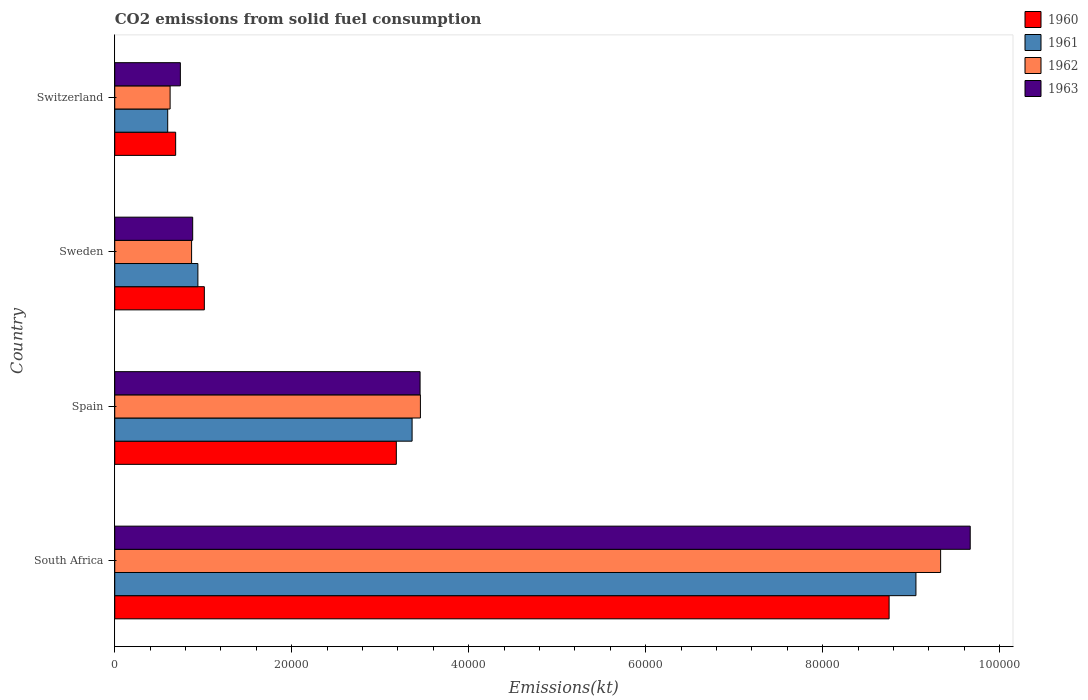How many different coloured bars are there?
Offer a terse response. 4. How many groups of bars are there?
Make the answer very short. 4. How many bars are there on the 1st tick from the top?
Give a very brief answer. 4. How many bars are there on the 3rd tick from the bottom?
Give a very brief answer. 4. What is the label of the 2nd group of bars from the top?
Keep it short and to the point. Sweden. What is the amount of CO2 emitted in 1961 in South Africa?
Ensure brevity in your answer.  9.05e+04. Across all countries, what is the maximum amount of CO2 emitted in 1960?
Keep it short and to the point. 8.75e+04. Across all countries, what is the minimum amount of CO2 emitted in 1963?
Provide a short and direct response. 7414.67. In which country was the amount of CO2 emitted in 1960 maximum?
Provide a short and direct response. South Africa. In which country was the amount of CO2 emitted in 1960 minimum?
Make the answer very short. Switzerland. What is the total amount of CO2 emitted in 1960 in the graph?
Make the answer very short. 1.36e+05. What is the difference between the amount of CO2 emitted in 1963 in Sweden and that in Switzerland?
Your answer should be compact. 1393.46. What is the difference between the amount of CO2 emitted in 1960 in South Africa and the amount of CO2 emitted in 1963 in Spain?
Offer a very short reply. 5.30e+04. What is the average amount of CO2 emitted in 1961 per country?
Keep it short and to the point. 3.49e+04. What is the difference between the amount of CO2 emitted in 1962 and amount of CO2 emitted in 1961 in Switzerland?
Make the answer very short. 271.36. What is the ratio of the amount of CO2 emitted in 1960 in South Africa to that in Spain?
Your response must be concise. 2.75. Is the amount of CO2 emitted in 1963 in Spain less than that in Sweden?
Offer a terse response. No. Is the difference between the amount of CO2 emitted in 1962 in Spain and Sweden greater than the difference between the amount of CO2 emitted in 1961 in Spain and Sweden?
Your response must be concise. Yes. What is the difference between the highest and the second highest amount of CO2 emitted in 1961?
Your answer should be compact. 5.69e+04. What is the difference between the highest and the lowest amount of CO2 emitted in 1962?
Ensure brevity in your answer.  8.71e+04. Is the sum of the amount of CO2 emitted in 1963 in South Africa and Spain greater than the maximum amount of CO2 emitted in 1962 across all countries?
Keep it short and to the point. Yes. Is it the case that in every country, the sum of the amount of CO2 emitted in 1963 and amount of CO2 emitted in 1962 is greater than the sum of amount of CO2 emitted in 1960 and amount of CO2 emitted in 1961?
Provide a short and direct response. No. Are all the bars in the graph horizontal?
Ensure brevity in your answer.  Yes. Are the values on the major ticks of X-axis written in scientific E-notation?
Ensure brevity in your answer.  No. Does the graph contain any zero values?
Offer a very short reply. No. How many legend labels are there?
Provide a succinct answer. 4. How are the legend labels stacked?
Provide a succinct answer. Vertical. What is the title of the graph?
Provide a succinct answer. CO2 emissions from solid fuel consumption. Does "1992" appear as one of the legend labels in the graph?
Your response must be concise. No. What is the label or title of the X-axis?
Give a very brief answer. Emissions(kt). What is the label or title of the Y-axis?
Make the answer very short. Country. What is the Emissions(kt) in 1960 in South Africa?
Your response must be concise. 8.75e+04. What is the Emissions(kt) in 1961 in South Africa?
Keep it short and to the point. 9.05e+04. What is the Emissions(kt) of 1962 in South Africa?
Offer a terse response. 9.33e+04. What is the Emissions(kt) in 1963 in South Africa?
Your response must be concise. 9.67e+04. What is the Emissions(kt) in 1960 in Spain?
Ensure brevity in your answer.  3.18e+04. What is the Emissions(kt) in 1961 in Spain?
Ensure brevity in your answer.  3.36e+04. What is the Emissions(kt) in 1962 in Spain?
Make the answer very short. 3.45e+04. What is the Emissions(kt) in 1963 in Spain?
Your response must be concise. 3.45e+04. What is the Emissions(kt) of 1960 in Sweden?
Offer a very short reply. 1.01e+04. What is the Emissions(kt) of 1961 in Sweden?
Provide a short and direct response. 9394.85. What is the Emissions(kt) of 1962 in Sweden?
Ensure brevity in your answer.  8683.46. What is the Emissions(kt) in 1963 in Sweden?
Offer a very short reply. 8808.13. What is the Emissions(kt) of 1960 in Switzerland?
Give a very brief answer. 6882.96. What is the Emissions(kt) of 1961 in Switzerland?
Ensure brevity in your answer.  5984.54. What is the Emissions(kt) in 1962 in Switzerland?
Your answer should be very brief. 6255.9. What is the Emissions(kt) of 1963 in Switzerland?
Make the answer very short. 7414.67. Across all countries, what is the maximum Emissions(kt) of 1960?
Ensure brevity in your answer.  8.75e+04. Across all countries, what is the maximum Emissions(kt) of 1961?
Ensure brevity in your answer.  9.05e+04. Across all countries, what is the maximum Emissions(kt) in 1962?
Provide a short and direct response. 9.33e+04. Across all countries, what is the maximum Emissions(kt) in 1963?
Ensure brevity in your answer.  9.67e+04. Across all countries, what is the minimum Emissions(kt) in 1960?
Keep it short and to the point. 6882.96. Across all countries, what is the minimum Emissions(kt) of 1961?
Give a very brief answer. 5984.54. Across all countries, what is the minimum Emissions(kt) of 1962?
Provide a short and direct response. 6255.9. Across all countries, what is the minimum Emissions(kt) in 1963?
Give a very brief answer. 7414.67. What is the total Emissions(kt) of 1960 in the graph?
Your answer should be compact. 1.36e+05. What is the total Emissions(kt) in 1961 in the graph?
Make the answer very short. 1.40e+05. What is the total Emissions(kt) in 1962 in the graph?
Your answer should be very brief. 1.43e+05. What is the total Emissions(kt) of 1963 in the graph?
Provide a short and direct response. 1.47e+05. What is the difference between the Emissions(kt) in 1960 in South Africa and that in Spain?
Ensure brevity in your answer.  5.57e+04. What is the difference between the Emissions(kt) of 1961 in South Africa and that in Spain?
Give a very brief answer. 5.69e+04. What is the difference between the Emissions(kt) in 1962 in South Africa and that in Spain?
Your answer should be very brief. 5.88e+04. What is the difference between the Emissions(kt) of 1963 in South Africa and that in Spain?
Provide a short and direct response. 6.22e+04. What is the difference between the Emissions(kt) in 1960 in South Africa and that in Sweden?
Offer a terse response. 7.74e+04. What is the difference between the Emissions(kt) of 1961 in South Africa and that in Sweden?
Your answer should be compact. 8.12e+04. What is the difference between the Emissions(kt) in 1962 in South Africa and that in Sweden?
Your response must be concise. 8.47e+04. What is the difference between the Emissions(kt) in 1963 in South Africa and that in Sweden?
Keep it short and to the point. 8.79e+04. What is the difference between the Emissions(kt) of 1960 in South Africa and that in Switzerland?
Provide a short and direct response. 8.06e+04. What is the difference between the Emissions(kt) of 1961 in South Africa and that in Switzerland?
Keep it short and to the point. 8.46e+04. What is the difference between the Emissions(kt) in 1962 in South Africa and that in Switzerland?
Your answer should be very brief. 8.71e+04. What is the difference between the Emissions(kt) of 1963 in South Africa and that in Switzerland?
Offer a terse response. 8.93e+04. What is the difference between the Emissions(kt) of 1960 in Spain and that in Sweden?
Your answer should be very brief. 2.17e+04. What is the difference between the Emissions(kt) of 1961 in Spain and that in Sweden?
Your answer should be compact. 2.42e+04. What is the difference between the Emissions(kt) of 1962 in Spain and that in Sweden?
Your answer should be compact. 2.59e+04. What is the difference between the Emissions(kt) in 1963 in Spain and that in Sweden?
Your answer should be very brief. 2.57e+04. What is the difference between the Emissions(kt) of 1960 in Spain and that in Switzerland?
Keep it short and to the point. 2.49e+04. What is the difference between the Emissions(kt) of 1961 in Spain and that in Switzerland?
Provide a succinct answer. 2.76e+04. What is the difference between the Emissions(kt) in 1962 in Spain and that in Switzerland?
Provide a short and direct response. 2.83e+04. What is the difference between the Emissions(kt) in 1963 in Spain and that in Switzerland?
Give a very brief answer. 2.71e+04. What is the difference between the Emissions(kt) in 1960 in Sweden and that in Switzerland?
Offer a terse response. 3241.63. What is the difference between the Emissions(kt) in 1961 in Sweden and that in Switzerland?
Offer a terse response. 3410.31. What is the difference between the Emissions(kt) in 1962 in Sweden and that in Switzerland?
Offer a very short reply. 2427.55. What is the difference between the Emissions(kt) in 1963 in Sweden and that in Switzerland?
Ensure brevity in your answer.  1393.46. What is the difference between the Emissions(kt) of 1960 in South Africa and the Emissions(kt) of 1961 in Spain?
Your answer should be very brief. 5.39e+04. What is the difference between the Emissions(kt) in 1960 in South Africa and the Emissions(kt) in 1962 in Spain?
Your answer should be compact. 5.30e+04. What is the difference between the Emissions(kt) of 1960 in South Africa and the Emissions(kt) of 1963 in Spain?
Ensure brevity in your answer.  5.30e+04. What is the difference between the Emissions(kt) of 1961 in South Africa and the Emissions(kt) of 1962 in Spain?
Make the answer very short. 5.60e+04. What is the difference between the Emissions(kt) in 1961 in South Africa and the Emissions(kt) in 1963 in Spain?
Offer a terse response. 5.60e+04. What is the difference between the Emissions(kt) in 1962 in South Africa and the Emissions(kt) in 1963 in Spain?
Offer a very short reply. 5.88e+04. What is the difference between the Emissions(kt) of 1960 in South Africa and the Emissions(kt) of 1961 in Sweden?
Give a very brief answer. 7.81e+04. What is the difference between the Emissions(kt) of 1960 in South Africa and the Emissions(kt) of 1962 in Sweden?
Offer a very short reply. 7.88e+04. What is the difference between the Emissions(kt) in 1960 in South Africa and the Emissions(kt) in 1963 in Sweden?
Offer a terse response. 7.87e+04. What is the difference between the Emissions(kt) of 1961 in South Africa and the Emissions(kt) of 1962 in Sweden?
Keep it short and to the point. 8.19e+04. What is the difference between the Emissions(kt) in 1961 in South Africa and the Emissions(kt) in 1963 in Sweden?
Give a very brief answer. 8.17e+04. What is the difference between the Emissions(kt) of 1962 in South Africa and the Emissions(kt) of 1963 in Sweden?
Keep it short and to the point. 8.45e+04. What is the difference between the Emissions(kt) in 1960 in South Africa and the Emissions(kt) in 1961 in Switzerland?
Ensure brevity in your answer.  8.15e+04. What is the difference between the Emissions(kt) of 1960 in South Africa and the Emissions(kt) of 1962 in Switzerland?
Provide a short and direct response. 8.13e+04. What is the difference between the Emissions(kt) of 1960 in South Africa and the Emissions(kt) of 1963 in Switzerland?
Your response must be concise. 8.01e+04. What is the difference between the Emissions(kt) of 1961 in South Africa and the Emissions(kt) of 1962 in Switzerland?
Make the answer very short. 8.43e+04. What is the difference between the Emissions(kt) in 1961 in South Africa and the Emissions(kt) in 1963 in Switzerland?
Your response must be concise. 8.31e+04. What is the difference between the Emissions(kt) of 1962 in South Africa and the Emissions(kt) of 1963 in Switzerland?
Provide a succinct answer. 8.59e+04. What is the difference between the Emissions(kt) of 1960 in Spain and the Emissions(kt) of 1961 in Sweden?
Offer a terse response. 2.24e+04. What is the difference between the Emissions(kt) of 1960 in Spain and the Emissions(kt) of 1962 in Sweden?
Make the answer very short. 2.31e+04. What is the difference between the Emissions(kt) in 1960 in Spain and the Emissions(kt) in 1963 in Sweden?
Your answer should be very brief. 2.30e+04. What is the difference between the Emissions(kt) in 1961 in Spain and the Emissions(kt) in 1962 in Sweden?
Make the answer very short. 2.49e+04. What is the difference between the Emissions(kt) of 1961 in Spain and the Emissions(kt) of 1963 in Sweden?
Your response must be concise. 2.48e+04. What is the difference between the Emissions(kt) in 1962 in Spain and the Emissions(kt) in 1963 in Sweden?
Provide a succinct answer. 2.57e+04. What is the difference between the Emissions(kt) in 1960 in Spain and the Emissions(kt) in 1961 in Switzerland?
Give a very brief answer. 2.58e+04. What is the difference between the Emissions(kt) of 1960 in Spain and the Emissions(kt) of 1962 in Switzerland?
Give a very brief answer. 2.56e+04. What is the difference between the Emissions(kt) in 1960 in Spain and the Emissions(kt) in 1963 in Switzerland?
Keep it short and to the point. 2.44e+04. What is the difference between the Emissions(kt) of 1961 in Spain and the Emissions(kt) of 1962 in Switzerland?
Your response must be concise. 2.73e+04. What is the difference between the Emissions(kt) in 1961 in Spain and the Emissions(kt) in 1963 in Switzerland?
Your answer should be very brief. 2.62e+04. What is the difference between the Emissions(kt) of 1962 in Spain and the Emissions(kt) of 1963 in Switzerland?
Keep it short and to the point. 2.71e+04. What is the difference between the Emissions(kt) of 1960 in Sweden and the Emissions(kt) of 1961 in Switzerland?
Keep it short and to the point. 4140.04. What is the difference between the Emissions(kt) of 1960 in Sweden and the Emissions(kt) of 1962 in Switzerland?
Offer a terse response. 3868.68. What is the difference between the Emissions(kt) in 1960 in Sweden and the Emissions(kt) in 1963 in Switzerland?
Your answer should be compact. 2709.91. What is the difference between the Emissions(kt) in 1961 in Sweden and the Emissions(kt) in 1962 in Switzerland?
Make the answer very short. 3138.95. What is the difference between the Emissions(kt) in 1961 in Sweden and the Emissions(kt) in 1963 in Switzerland?
Ensure brevity in your answer.  1980.18. What is the difference between the Emissions(kt) of 1962 in Sweden and the Emissions(kt) of 1963 in Switzerland?
Your answer should be very brief. 1268.78. What is the average Emissions(kt) of 1960 per country?
Ensure brevity in your answer.  3.41e+04. What is the average Emissions(kt) in 1961 per country?
Your answer should be compact. 3.49e+04. What is the average Emissions(kt) of 1962 per country?
Offer a very short reply. 3.57e+04. What is the average Emissions(kt) of 1963 per country?
Your answer should be compact. 3.69e+04. What is the difference between the Emissions(kt) of 1960 and Emissions(kt) of 1961 in South Africa?
Your response must be concise. -3032.61. What is the difference between the Emissions(kt) in 1960 and Emissions(kt) in 1962 in South Africa?
Ensure brevity in your answer.  -5823.2. What is the difference between the Emissions(kt) of 1960 and Emissions(kt) of 1963 in South Africa?
Ensure brevity in your answer.  -9167.5. What is the difference between the Emissions(kt) of 1961 and Emissions(kt) of 1962 in South Africa?
Make the answer very short. -2790.59. What is the difference between the Emissions(kt) of 1961 and Emissions(kt) of 1963 in South Africa?
Make the answer very short. -6134.89. What is the difference between the Emissions(kt) of 1962 and Emissions(kt) of 1963 in South Africa?
Give a very brief answer. -3344.3. What is the difference between the Emissions(kt) of 1960 and Emissions(kt) of 1961 in Spain?
Offer a terse response. -1782.16. What is the difference between the Emissions(kt) of 1960 and Emissions(kt) of 1962 in Spain?
Your answer should be compact. -2720.91. What is the difference between the Emissions(kt) in 1960 and Emissions(kt) in 1963 in Spain?
Offer a very short reply. -2684.24. What is the difference between the Emissions(kt) in 1961 and Emissions(kt) in 1962 in Spain?
Your answer should be very brief. -938.75. What is the difference between the Emissions(kt) of 1961 and Emissions(kt) of 1963 in Spain?
Provide a short and direct response. -902.08. What is the difference between the Emissions(kt) in 1962 and Emissions(kt) in 1963 in Spain?
Offer a terse response. 36.67. What is the difference between the Emissions(kt) of 1960 and Emissions(kt) of 1961 in Sweden?
Keep it short and to the point. 729.73. What is the difference between the Emissions(kt) of 1960 and Emissions(kt) of 1962 in Sweden?
Your answer should be compact. 1441.13. What is the difference between the Emissions(kt) in 1960 and Emissions(kt) in 1963 in Sweden?
Provide a succinct answer. 1316.45. What is the difference between the Emissions(kt) of 1961 and Emissions(kt) of 1962 in Sweden?
Make the answer very short. 711.4. What is the difference between the Emissions(kt) in 1961 and Emissions(kt) in 1963 in Sweden?
Make the answer very short. 586.72. What is the difference between the Emissions(kt) of 1962 and Emissions(kt) of 1963 in Sweden?
Make the answer very short. -124.68. What is the difference between the Emissions(kt) of 1960 and Emissions(kt) of 1961 in Switzerland?
Your answer should be compact. 898.41. What is the difference between the Emissions(kt) of 1960 and Emissions(kt) of 1962 in Switzerland?
Make the answer very short. 627.06. What is the difference between the Emissions(kt) in 1960 and Emissions(kt) in 1963 in Switzerland?
Give a very brief answer. -531.72. What is the difference between the Emissions(kt) in 1961 and Emissions(kt) in 1962 in Switzerland?
Provide a succinct answer. -271.36. What is the difference between the Emissions(kt) of 1961 and Emissions(kt) of 1963 in Switzerland?
Your response must be concise. -1430.13. What is the difference between the Emissions(kt) in 1962 and Emissions(kt) in 1963 in Switzerland?
Your answer should be compact. -1158.77. What is the ratio of the Emissions(kt) in 1960 in South Africa to that in Spain?
Provide a succinct answer. 2.75. What is the ratio of the Emissions(kt) in 1961 in South Africa to that in Spain?
Keep it short and to the point. 2.69. What is the ratio of the Emissions(kt) of 1962 in South Africa to that in Spain?
Provide a succinct answer. 2.7. What is the ratio of the Emissions(kt) in 1963 in South Africa to that in Spain?
Give a very brief answer. 2.8. What is the ratio of the Emissions(kt) of 1960 in South Africa to that in Sweden?
Provide a short and direct response. 8.64. What is the ratio of the Emissions(kt) in 1961 in South Africa to that in Sweden?
Your answer should be very brief. 9.64. What is the ratio of the Emissions(kt) of 1962 in South Africa to that in Sweden?
Offer a terse response. 10.75. What is the ratio of the Emissions(kt) of 1963 in South Africa to that in Sweden?
Provide a succinct answer. 10.98. What is the ratio of the Emissions(kt) in 1960 in South Africa to that in Switzerland?
Give a very brief answer. 12.71. What is the ratio of the Emissions(kt) in 1961 in South Africa to that in Switzerland?
Ensure brevity in your answer.  15.13. What is the ratio of the Emissions(kt) in 1962 in South Africa to that in Switzerland?
Provide a short and direct response. 14.92. What is the ratio of the Emissions(kt) of 1963 in South Africa to that in Switzerland?
Your answer should be very brief. 13.04. What is the ratio of the Emissions(kt) in 1960 in Spain to that in Sweden?
Provide a succinct answer. 3.14. What is the ratio of the Emissions(kt) of 1961 in Spain to that in Sweden?
Provide a succinct answer. 3.58. What is the ratio of the Emissions(kt) in 1962 in Spain to that in Sweden?
Give a very brief answer. 3.98. What is the ratio of the Emissions(kt) in 1963 in Spain to that in Sweden?
Give a very brief answer. 3.92. What is the ratio of the Emissions(kt) of 1960 in Spain to that in Switzerland?
Keep it short and to the point. 4.62. What is the ratio of the Emissions(kt) of 1961 in Spain to that in Switzerland?
Ensure brevity in your answer.  5.62. What is the ratio of the Emissions(kt) in 1962 in Spain to that in Switzerland?
Give a very brief answer. 5.52. What is the ratio of the Emissions(kt) of 1963 in Spain to that in Switzerland?
Provide a succinct answer. 4.65. What is the ratio of the Emissions(kt) in 1960 in Sweden to that in Switzerland?
Your response must be concise. 1.47. What is the ratio of the Emissions(kt) of 1961 in Sweden to that in Switzerland?
Your response must be concise. 1.57. What is the ratio of the Emissions(kt) in 1962 in Sweden to that in Switzerland?
Your response must be concise. 1.39. What is the ratio of the Emissions(kt) of 1963 in Sweden to that in Switzerland?
Give a very brief answer. 1.19. What is the difference between the highest and the second highest Emissions(kt) of 1960?
Keep it short and to the point. 5.57e+04. What is the difference between the highest and the second highest Emissions(kt) of 1961?
Your answer should be very brief. 5.69e+04. What is the difference between the highest and the second highest Emissions(kt) in 1962?
Keep it short and to the point. 5.88e+04. What is the difference between the highest and the second highest Emissions(kt) in 1963?
Your answer should be compact. 6.22e+04. What is the difference between the highest and the lowest Emissions(kt) of 1960?
Give a very brief answer. 8.06e+04. What is the difference between the highest and the lowest Emissions(kt) of 1961?
Your answer should be very brief. 8.46e+04. What is the difference between the highest and the lowest Emissions(kt) of 1962?
Your answer should be very brief. 8.71e+04. What is the difference between the highest and the lowest Emissions(kt) in 1963?
Give a very brief answer. 8.93e+04. 